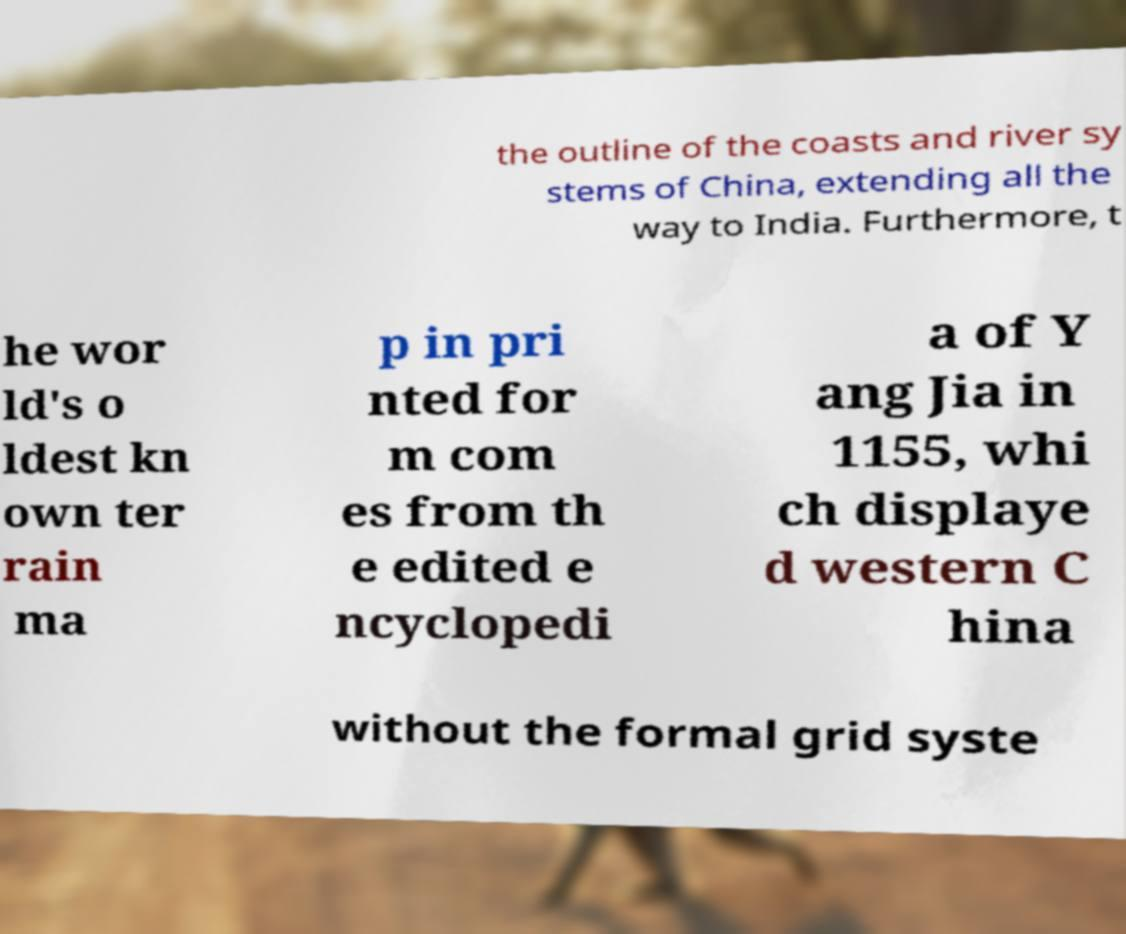Could you assist in decoding the text presented in this image and type it out clearly? the outline of the coasts and river sy stems of China, extending all the way to India. Furthermore, t he wor ld's o ldest kn own ter rain ma p in pri nted for m com es from th e edited e ncyclopedi a of Y ang Jia in 1155, whi ch displaye d western C hina without the formal grid syste 